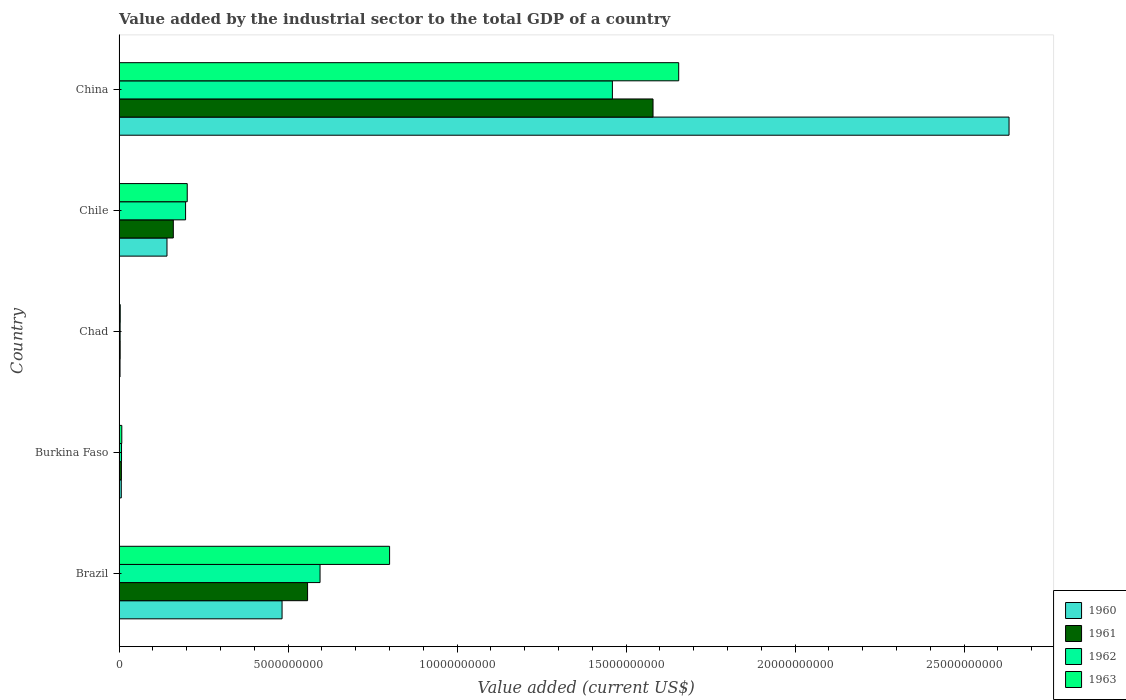How many different coloured bars are there?
Your response must be concise. 4. How many groups of bars are there?
Provide a short and direct response. 5. Are the number of bars per tick equal to the number of legend labels?
Your answer should be very brief. Yes. How many bars are there on the 4th tick from the top?
Provide a succinct answer. 4. What is the label of the 5th group of bars from the top?
Provide a short and direct response. Brazil. In how many cases, is the number of bars for a given country not equal to the number of legend labels?
Offer a very short reply. 0. What is the value added by the industrial sector to the total GDP in 1962 in Chile?
Offer a terse response. 1.97e+09. Across all countries, what is the maximum value added by the industrial sector to the total GDP in 1962?
Provide a succinct answer. 1.46e+1. Across all countries, what is the minimum value added by the industrial sector to the total GDP in 1962?
Keep it short and to the point. 3.17e+07. In which country was the value added by the industrial sector to the total GDP in 1963 minimum?
Keep it short and to the point. Chad. What is the total value added by the industrial sector to the total GDP in 1961 in the graph?
Offer a terse response. 2.31e+1. What is the difference between the value added by the industrial sector to the total GDP in 1963 in Brazil and that in China?
Keep it short and to the point. -8.55e+09. What is the difference between the value added by the industrial sector to the total GDP in 1962 in Chad and the value added by the industrial sector to the total GDP in 1963 in Brazil?
Your response must be concise. -7.97e+09. What is the average value added by the industrial sector to the total GDP in 1961 per country?
Your response must be concise. 4.62e+09. What is the difference between the value added by the industrial sector to the total GDP in 1962 and value added by the industrial sector to the total GDP in 1963 in Brazil?
Ensure brevity in your answer.  -2.06e+09. In how many countries, is the value added by the industrial sector to the total GDP in 1960 greater than 10000000000 US$?
Your answer should be compact. 1. What is the ratio of the value added by the industrial sector to the total GDP in 1961 in Brazil to that in Chad?
Your answer should be very brief. 170.8. What is the difference between the highest and the second highest value added by the industrial sector to the total GDP in 1963?
Offer a terse response. 8.55e+09. What is the difference between the highest and the lowest value added by the industrial sector to the total GDP in 1961?
Give a very brief answer. 1.58e+1. In how many countries, is the value added by the industrial sector to the total GDP in 1961 greater than the average value added by the industrial sector to the total GDP in 1961 taken over all countries?
Offer a terse response. 2. Is the sum of the value added by the industrial sector to the total GDP in 1962 in Burkina Faso and Chad greater than the maximum value added by the industrial sector to the total GDP in 1960 across all countries?
Make the answer very short. No. What does the 3rd bar from the top in Burkina Faso represents?
Offer a very short reply. 1961. Is it the case that in every country, the sum of the value added by the industrial sector to the total GDP in 1961 and value added by the industrial sector to the total GDP in 1960 is greater than the value added by the industrial sector to the total GDP in 1962?
Keep it short and to the point. Yes. How many countries are there in the graph?
Your answer should be compact. 5. Does the graph contain grids?
Provide a succinct answer. No. How many legend labels are there?
Provide a succinct answer. 4. What is the title of the graph?
Keep it short and to the point. Value added by the industrial sector to the total GDP of a country. Does "1971" appear as one of the legend labels in the graph?
Your answer should be compact. No. What is the label or title of the X-axis?
Keep it short and to the point. Value added (current US$). What is the label or title of the Y-axis?
Give a very brief answer. Country. What is the Value added (current US$) of 1960 in Brazil?
Ensure brevity in your answer.  4.82e+09. What is the Value added (current US$) in 1961 in Brazil?
Your answer should be compact. 5.58e+09. What is the Value added (current US$) of 1962 in Brazil?
Provide a succinct answer. 5.95e+09. What is the Value added (current US$) of 1963 in Brazil?
Offer a very short reply. 8.00e+09. What is the Value added (current US$) of 1960 in Burkina Faso?
Keep it short and to the point. 6.58e+07. What is the Value added (current US$) of 1961 in Burkina Faso?
Give a very brief answer. 6.97e+07. What is the Value added (current US$) of 1962 in Burkina Faso?
Provide a short and direct response. 7.35e+07. What is the Value added (current US$) in 1963 in Burkina Faso?
Give a very brief answer. 8.13e+07. What is the Value added (current US$) of 1960 in Chad?
Offer a very short reply. 2.88e+07. What is the Value added (current US$) of 1961 in Chad?
Provide a short and direct response. 3.27e+07. What is the Value added (current US$) in 1962 in Chad?
Ensure brevity in your answer.  3.17e+07. What is the Value added (current US$) of 1963 in Chad?
Your response must be concise. 3.49e+07. What is the Value added (current US$) in 1960 in Chile?
Provide a succinct answer. 1.42e+09. What is the Value added (current US$) of 1961 in Chile?
Provide a succinct answer. 1.61e+09. What is the Value added (current US$) in 1962 in Chile?
Make the answer very short. 1.97e+09. What is the Value added (current US$) of 1963 in Chile?
Your answer should be very brief. 2.02e+09. What is the Value added (current US$) in 1960 in China?
Provide a succinct answer. 2.63e+1. What is the Value added (current US$) of 1961 in China?
Keep it short and to the point. 1.58e+1. What is the Value added (current US$) in 1962 in China?
Give a very brief answer. 1.46e+1. What is the Value added (current US$) in 1963 in China?
Your answer should be compact. 1.66e+1. Across all countries, what is the maximum Value added (current US$) in 1960?
Give a very brief answer. 2.63e+1. Across all countries, what is the maximum Value added (current US$) in 1961?
Offer a very short reply. 1.58e+1. Across all countries, what is the maximum Value added (current US$) in 1962?
Make the answer very short. 1.46e+1. Across all countries, what is the maximum Value added (current US$) of 1963?
Your answer should be very brief. 1.66e+1. Across all countries, what is the minimum Value added (current US$) of 1960?
Ensure brevity in your answer.  2.88e+07. Across all countries, what is the minimum Value added (current US$) of 1961?
Your response must be concise. 3.27e+07. Across all countries, what is the minimum Value added (current US$) of 1962?
Your answer should be compact. 3.17e+07. Across all countries, what is the minimum Value added (current US$) of 1963?
Your response must be concise. 3.49e+07. What is the total Value added (current US$) of 1960 in the graph?
Provide a short and direct response. 3.27e+1. What is the total Value added (current US$) of 1961 in the graph?
Offer a very short reply. 2.31e+1. What is the total Value added (current US$) in 1962 in the graph?
Provide a short and direct response. 2.26e+1. What is the total Value added (current US$) of 1963 in the graph?
Offer a very short reply. 2.67e+1. What is the difference between the Value added (current US$) in 1960 in Brazil and that in Burkina Faso?
Your answer should be compact. 4.76e+09. What is the difference between the Value added (current US$) of 1961 in Brazil and that in Burkina Faso?
Give a very brief answer. 5.51e+09. What is the difference between the Value added (current US$) in 1962 in Brazil and that in Burkina Faso?
Your answer should be compact. 5.87e+09. What is the difference between the Value added (current US$) of 1963 in Brazil and that in Burkina Faso?
Your answer should be compact. 7.92e+09. What is the difference between the Value added (current US$) in 1960 in Brazil and that in Chad?
Your answer should be compact. 4.79e+09. What is the difference between the Value added (current US$) of 1961 in Brazil and that in Chad?
Give a very brief answer. 5.54e+09. What is the difference between the Value added (current US$) of 1962 in Brazil and that in Chad?
Your response must be concise. 5.91e+09. What is the difference between the Value added (current US$) of 1963 in Brazil and that in Chad?
Provide a short and direct response. 7.97e+09. What is the difference between the Value added (current US$) of 1960 in Brazil and that in Chile?
Make the answer very short. 3.40e+09. What is the difference between the Value added (current US$) in 1961 in Brazil and that in Chile?
Your answer should be very brief. 3.97e+09. What is the difference between the Value added (current US$) of 1962 in Brazil and that in Chile?
Make the answer very short. 3.98e+09. What is the difference between the Value added (current US$) of 1963 in Brazil and that in Chile?
Give a very brief answer. 5.99e+09. What is the difference between the Value added (current US$) in 1960 in Brazil and that in China?
Give a very brief answer. -2.15e+1. What is the difference between the Value added (current US$) of 1961 in Brazil and that in China?
Your answer should be very brief. -1.02e+1. What is the difference between the Value added (current US$) in 1962 in Brazil and that in China?
Provide a short and direct response. -8.65e+09. What is the difference between the Value added (current US$) of 1963 in Brazil and that in China?
Your answer should be compact. -8.55e+09. What is the difference between the Value added (current US$) of 1960 in Burkina Faso and that in Chad?
Provide a succinct answer. 3.70e+07. What is the difference between the Value added (current US$) in 1961 in Burkina Faso and that in Chad?
Offer a very short reply. 3.70e+07. What is the difference between the Value added (current US$) in 1962 in Burkina Faso and that in Chad?
Your response must be concise. 4.18e+07. What is the difference between the Value added (current US$) in 1963 in Burkina Faso and that in Chad?
Ensure brevity in your answer.  4.64e+07. What is the difference between the Value added (current US$) in 1960 in Burkina Faso and that in Chile?
Offer a very short reply. -1.35e+09. What is the difference between the Value added (current US$) of 1961 in Burkina Faso and that in Chile?
Your response must be concise. -1.54e+09. What is the difference between the Value added (current US$) in 1962 in Burkina Faso and that in Chile?
Your answer should be very brief. -1.89e+09. What is the difference between the Value added (current US$) in 1963 in Burkina Faso and that in Chile?
Your response must be concise. -1.94e+09. What is the difference between the Value added (current US$) of 1960 in Burkina Faso and that in China?
Give a very brief answer. -2.63e+1. What is the difference between the Value added (current US$) in 1961 in Burkina Faso and that in China?
Provide a succinct answer. -1.57e+1. What is the difference between the Value added (current US$) of 1962 in Burkina Faso and that in China?
Offer a very short reply. -1.45e+1. What is the difference between the Value added (current US$) in 1963 in Burkina Faso and that in China?
Keep it short and to the point. -1.65e+1. What is the difference between the Value added (current US$) of 1960 in Chad and that in Chile?
Your response must be concise. -1.39e+09. What is the difference between the Value added (current US$) in 1961 in Chad and that in Chile?
Your answer should be compact. -1.57e+09. What is the difference between the Value added (current US$) of 1962 in Chad and that in Chile?
Give a very brief answer. -1.94e+09. What is the difference between the Value added (current US$) in 1963 in Chad and that in Chile?
Provide a short and direct response. -1.98e+09. What is the difference between the Value added (current US$) in 1960 in Chad and that in China?
Provide a short and direct response. -2.63e+1. What is the difference between the Value added (current US$) of 1961 in Chad and that in China?
Your response must be concise. -1.58e+1. What is the difference between the Value added (current US$) in 1962 in Chad and that in China?
Your answer should be very brief. -1.46e+1. What is the difference between the Value added (current US$) in 1963 in Chad and that in China?
Give a very brief answer. -1.65e+1. What is the difference between the Value added (current US$) of 1960 in Chile and that in China?
Keep it short and to the point. -2.49e+1. What is the difference between the Value added (current US$) of 1961 in Chile and that in China?
Provide a short and direct response. -1.42e+1. What is the difference between the Value added (current US$) in 1962 in Chile and that in China?
Provide a short and direct response. -1.26e+1. What is the difference between the Value added (current US$) of 1963 in Chile and that in China?
Ensure brevity in your answer.  -1.45e+1. What is the difference between the Value added (current US$) in 1960 in Brazil and the Value added (current US$) in 1961 in Burkina Faso?
Your answer should be compact. 4.75e+09. What is the difference between the Value added (current US$) in 1960 in Brazil and the Value added (current US$) in 1962 in Burkina Faso?
Ensure brevity in your answer.  4.75e+09. What is the difference between the Value added (current US$) of 1960 in Brazil and the Value added (current US$) of 1963 in Burkina Faso?
Your answer should be very brief. 4.74e+09. What is the difference between the Value added (current US$) of 1961 in Brazil and the Value added (current US$) of 1962 in Burkina Faso?
Offer a very short reply. 5.50e+09. What is the difference between the Value added (current US$) in 1961 in Brazil and the Value added (current US$) in 1963 in Burkina Faso?
Ensure brevity in your answer.  5.50e+09. What is the difference between the Value added (current US$) of 1962 in Brazil and the Value added (current US$) of 1963 in Burkina Faso?
Provide a short and direct response. 5.86e+09. What is the difference between the Value added (current US$) of 1960 in Brazil and the Value added (current US$) of 1961 in Chad?
Keep it short and to the point. 4.79e+09. What is the difference between the Value added (current US$) in 1960 in Brazil and the Value added (current US$) in 1962 in Chad?
Offer a terse response. 4.79e+09. What is the difference between the Value added (current US$) of 1960 in Brazil and the Value added (current US$) of 1963 in Chad?
Make the answer very short. 4.79e+09. What is the difference between the Value added (current US$) in 1961 in Brazil and the Value added (current US$) in 1962 in Chad?
Provide a succinct answer. 5.55e+09. What is the difference between the Value added (current US$) of 1961 in Brazil and the Value added (current US$) of 1963 in Chad?
Your answer should be very brief. 5.54e+09. What is the difference between the Value added (current US$) in 1962 in Brazil and the Value added (current US$) in 1963 in Chad?
Offer a very short reply. 5.91e+09. What is the difference between the Value added (current US$) in 1960 in Brazil and the Value added (current US$) in 1961 in Chile?
Your response must be concise. 3.22e+09. What is the difference between the Value added (current US$) of 1960 in Brazil and the Value added (current US$) of 1962 in Chile?
Offer a terse response. 2.85e+09. What is the difference between the Value added (current US$) of 1960 in Brazil and the Value added (current US$) of 1963 in Chile?
Make the answer very short. 2.81e+09. What is the difference between the Value added (current US$) in 1961 in Brazil and the Value added (current US$) in 1962 in Chile?
Ensure brevity in your answer.  3.61e+09. What is the difference between the Value added (current US$) of 1961 in Brazil and the Value added (current US$) of 1963 in Chile?
Provide a short and direct response. 3.56e+09. What is the difference between the Value added (current US$) in 1962 in Brazil and the Value added (current US$) in 1963 in Chile?
Your answer should be compact. 3.93e+09. What is the difference between the Value added (current US$) of 1960 in Brazil and the Value added (current US$) of 1961 in China?
Your answer should be compact. -1.10e+1. What is the difference between the Value added (current US$) in 1960 in Brazil and the Value added (current US$) in 1962 in China?
Provide a short and direct response. -9.77e+09. What is the difference between the Value added (current US$) in 1960 in Brazil and the Value added (current US$) in 1963 in China?
Give a very brief answer. -1.17e+1. What is the difference between the Value added (current US$) of 1961 in Brazil and the Value added (current US$) of 1962 in China?
Ensure brevity in your answer.  -9.02e+09. What is the difference between the Value added (current US$) of 1961 in Brazil and the Value added (current US$) of 1963 in China?
Your answer should be compact. -1.10e+1. What is the difference between the Value added (current US$) in 1962 in Brazil and the Value added (current US$) in 1963 in China?
Your response must be concise. -1.06e+1. What is the difference between the Value added (current US$) of 1960 in Burkina Faso and the Value added (current US$) of 1961 in Chad?
Your answer should be compact. 3.32e+07. What is the difference between the Value added (current US$) in 1960 in Burkina Faso and the Value added (current US$) in 1962 in Chad?
Make the answer very short. 3.41e+07. What is the difference between the Value added (current US$) in 1960 in Burkina Faso and the Value added (current US$) in 1963 in Chad?
Your answer should be compact. 3.09e+07. What is the difference between the Value added (current US$) of 1961 in Burkina Faso and the Value added (current US$) of 1962 in Chad?
Ensure brevity in your answer.  3.79e+07. What is the difference between the Value added (current US$) in 1961 in Burkina Faso and the Value added (current US$) in 1963 in Chad?
Provide a succinct answer. 3.48e+07. What is the difference between the Value added (current US$) of 1962 in Burkina Faso and the Value added (current US$) of 1963 in Chad?
Keep it short and to the point. 3.86e+07. What is the difference between the Value added (current US$) of 1960 in Burkina Faso and the Value added (current US$) of 1961 in Chile?
Your answer should be compact. -1.54e+09. What is the difference between the Value added (current US$) of 1960 in Burkina Faso and the Value added (current US$) of 1962 in Chile?
Provide a succinct answer. -1.90e+09. What is the difference between the Value added (current US$) of 1960 in Burkina Faso and the Value added (current US$) of 1963 in Chile?
Offer a very short reply. -1.95e+09. What is the difference between the Value added (current US$) of 1961 in Burkina Faso and the Value added (current US$) of 1962 in Chile?
Make the answer very short. -1.90e+09. What is the difference between the Value added (current US$) in 1961 in Burkina Faso and the Value added (current US$) in 1963 in Chile?
Your response must be concise. -1.95e+09. What is the difference between the Value added (current US$) in 1962 in Burkina Faso and the Value added (current US$) in 1963 in Chile?
Make the answer very short. -1.94e+09. What is the difference between the Value added (current US$) in 1960 in Burkina Faso and the Value added (current US$) in 1961 in China?
Provide a succinct answer. -1.57e+1. What is the difference between the Value added (current US$) of 1960 in Burkina Faso and the Value added (current US$) of 1962 in China?
Keep it short and to the point. -1.45e+1. What is the difference between the Value added (current US$) of 1960 in Burkina Faso and the Value added (current US$) of 1963 in China?
Your response must be concise. -1.65e+1. What is the difference between the Value added (current US$) in 1961 in Burkina Faso and the Value added (current US$) in 1962 in China?
Provide a short and direct response. -1.45e+1. What is the difference between the Value added (current US$) of 1961 in Burkina Faso and the Value added (current US$) of 1963 in China?
Keep it short and to the point. -1.65e+1. What is the difference between the Value added (current US$) of 1962 in Burkina Faso and the Value added (current US$) of 1963 in China?
Your answer should be compact. -1.65e+1. What is the difference between the Value added (current US$) in 1960 in Chad and the Value added (current US$) in 1961 in Chile?
Provide a short and direct response. -1.58e+09. What is the difference between the Value added (current US$) in 1960 in Chad and the Value added (current US$) in 1962 in Chile?
Your answer should be compact. -1.94e+09. What is the difference between the Value added (current US$) in 1960 in Chad and the Value added (current US$) in 1963 in Chile?
Your answer should be compact. -1.99e+09. What is the difference between the Value added (current US$) in 1961 in Chad and the Value added (current US$) in 1962 in Chile?
Provide a short and direct response. -1.94e+09. What is the difference between the Value added (current US$) in 1961 in Chad and the Value added (current US$) in 1963 in Chile?
Offer a terse response. -1.98e+09. What is the difference between the Value added (current US$) in 1962 in Chad and the Value added (current US$) in 1963 in Chile?
Provide a short and direct response. -1.99e+09. What is the difference between the Value added (current US$) of 1960 in Chad and the Value added (current US$) of 1961 in China?
Give a very brief answer. -1.58e+1. What is the difference between the Value added (current US$) of 1960 in Chad and the Value added (current US$) of 1962 in China?
Provide a succinct answer. -1.46e+1. What is the difference between the Value added (current US$) in 1960 in Chad and the Value added (current US$) in 1963 in China?
Provide a short and direct response. -1.65e+1. What is the difference between the Value added (current US$) of 1961 in Chad and the Value added (current US$) of 1962 in China?
Offer a very short reply. -1.46e+1. What is the difference between the Value added (current US$) in 1961 in Chad and the Value added (current US$) in 1963 in China?
Provide a short and direct response. -1.65e+1. What is the difference between the Value added (current US$) in 1962 in Chad and the Value added (current US$) in 1963 in China?
Ensure brevity in your answer.  -1.65e+1. What is the difference between the Value added (current US$) in 1960 in Chile and the Value added (current US$) in 1961 in China?
Ensure brevity in your answer.  -1.44e+1. What is the difference between the Value added (current US$) of 1960 in Chile and the Value added (current US$) of 1962 in China?
Ensure brevity in your answer.  -1.32e+1. What is the difference between the Value added (current US$) in 1960 in Chile and the Value added (current US$) in 1963 in China?
Keep it short and to the point. -1.51e+1. What is the difference between the Value added (current US$) of 1961 in Chile and the Value added (current US$) of 1962 in China?
Your answer should be compact. -1.30e+1. What is the difference between the Value added (current US$) of 1961 in Chile and the Value added (current US$) of 1963 in China?
Your answer should be very brief. -1.50e+1. What is the difference between the Value added (current US$) of 1962 in Chile and the Value added (current US$) of 1963 in China?
Offer a very short reply. -1.46e+1. What is the average Value added (current US$) in 1960 per country?
Give a very brief answer. 6.53e+09. What is the average Value added (current US$) in 1961 per country?
Provide a succinct answer. 4.62e+09. What is the average Value added (current US$) in 1962 per country?
Keep it short and to the point. 4.52e+09. What is the average Value added (current US$) in 1963 per country?
Ensure brevity in your answer.  5.34e+09. What is the difference between the Value added (current US$) of 1960 and Value added (current US$) of 1961 in Brazil?
Offer a very short reply. -7.55e+08. What is the difference between the Value added (current US$) in 1960 and Value added (current US$) in 1962 in Brazil?
Keep it short and to the point. -1.12e+09. What is the difference between the Value added (current US$) of 1960 and Value added (current US$) of 1963 in Brazil?
Keep it short and to the point. -3.18e+09. What is the difference between the Value added (current US$) of 1961 and Value added (current US$) of 1962 in Brazil?
Make the answer very short. -3.69e+08. What is the difference between the Value added (current US$) in 1961 and Value added (current US$) in 1963 in Brazil?
Your response must be concise. -2.43e+09. What is the difference between the Value added (current US$) in 1962 and Value added (current US$) in 1963 in Brazil?
Ensure brevity in your answer.  -2.06e+09. What is the difference between the Value added (current US$) of 1960 and Value added (current US$) of 1961 in Burkina Faso?
Your answer should be compact. -3.88e+06. What is the difference between the Value added (current US$) in 1960 and Value added (current US$) in 1962 in Burkina Faso?
Your answer should be compact. -7.71e+06. What is the difference between the Value added (current US$) in 1960 and Value added (current US$) in 1963 in Burkina Faso?
Offer a terse response. -1.55e+07. What is the difference between the Value added (current US$) in 1961 and Value added (current US$) in 1962 in Burkina Faso?
Offer a terse response. -3.83e+06. What is the difference between the Value added (current US$) in 1961 and Value added (current US$) in 1963 in Burkina Faso?
Keep it short and to the point. -1.16e+07. What is the difference between the Value added (current US$) of 1962 and Value added (current US$) of 1963 in Burkina Faso?
Your answer should be compact. -7.75e+06. What is the difference between the Value added (current US$) in 1960 and Value added (current US$) in 1961 in Chad?
Provide a succinct answer. -3.82e+06. What is the difference between the Value added (current US$) of 1960 and Value added (current US$) of 1962 in Chad?
Your response must be concise. -2.90e+06. What is the difference between the Value added (current US$) of 1960 and Value added (current US$) of 1963 in Chad?
Give a very brief answer. -6.04e+06. What is the difference between the Value added (current US$) in 1961 and Value added (current US$) in 1962 in Chad?
Your answer should be very brief. 9.19e+05. What is the difference between the Value added (current US$) of 1961 and Value added (current US$) of 1963 in Chad?
Offer a very short reply. -2.22e+06. What is the difference between the Value added (current US$) of 1962 and Value added (current US$) of 1963 in Chad?
Provide a succinct answer. -3.14e+06. What is the difference between the Value added (current US$) in 1960 and Value added (current US$) in 1961 in Chile?
Make the answer very short. -1.88e+08. What is the difference between the Value added (current US$) in 1960 and Value added (current US$) in 1962 in Chile?
Your answer should be compact. -5.50e+08. What is the difference between the Value added (current US$) of 1960 and Value added (current US$) of 1963 in Chile?
Keep it short and to the point. -5.99e+08. What is the difference between the Value added (current US$) in 1961 and Value added (current US$) in 1962 in Chile?
Your answer should be very brief. -3.63e+08. What is the difference between the Value added (current US$) in 1961 and Value added (current US$) in 1963 in Chile?
Ensure brevity in your answer.  -4.12e+08. What is the difference between the Value added (current US$) in 1962 and Value added (current US$) in 1963 in Chile?
Your answer should be compact. -4.92e+07. What is the difference between the Value added (current US$) of 1960 and Value added (current US$) of 1961 in China?
Your answer should be very brief. 1.05e+1. What is the difference between the Value added (current US$) of 1960 and Value added (current US$) of 1962 in China?
Your answer should be compact. 1.17e+1. What is the difference between the Value added (current US$) in 1960 and Value added (current US$) in 1963 in China?
Your answer should be very brief. 9.77e+09. What is the difference between the Value added (current US$) of 1961 and Value added (current US$) of 1962 in China?
Your answer should be compact. 1.20e+09. What is the difference between the Value added (current US$) in 1961 and Value added (current US$) in 1963 in China?
Offer a terse response. -7.60e+08. What is the difference between the Value added (current US$) of 1962 and Value added (current US$) of 1963 in China?
Your answer should be very brief. -1.96e+09. What is the ratio of the Value added (current US$) of 1960 in Brazil to that in Burkina Faso?
Offer a terse response. 73.29. What is the ratio of the Value added (current US$) of 1961 in Brazil to that in Burkina Faso?
Your answer should be compact. 80.04. What is the ratio of the Value added (current US$) of 1962 in Brazil to that in Burkina Faso?
Your answer should be compact. 80.89. What is the ratio of the Value added (current US$) in 1963 in Brazil to that in Burkina Faso?
Keep it short and to the point. 98.49. What is the ratio of the Value added (current US$) in 1960 in Brazil to that in Chad?
Provide a short and direct response. 167.26. What is the ratio of the Value added (current US$) in 1961 in Brazil to that in Chad?
Your answer should be very brief. 170.8. What is the ratio of the Value added (current US$) in 1962 in Brazil to that in Chad?
Your answer should be compact. 187.38. What is the ratio of the Value added (current US$) in 1963 in Brazil to that in Chad?
Give a very brief answer. 229.53. What is the ratio of the Value added (current US$) in 1960 in Brazil to that in Chile?
Offer a very short reply. 3.4. What is the ratio of the Value added (current US$) in 1961 in Brazil to that in Chile?
Provide a short and direct response. 3.47. What is the ratio of the Value added (current US$) of 1962 in Brazil to that in Chile?
Provide a succinct answer. 3.02. What is the ratio of the Value added (current US$) in 1963 in Brazil to that in Chile?
Your answer should be compact. 3.97. What is the ratio of the Value added (current US$) in 1960 in Brazil to that in China?
Make the answer very short. 0.18. What is the ratio of the Value added (current US$) in 1961 in Brazil to that in China?
Ensure brevity in your answer.  0.35. What is the ratio of the Value added (current US$) in 1962 in Brazil to that in China?
Your answer should be compact. 0.41. What is the ratio of the Value added (current US$) of 1963 in Brazil to that in China?
Ensure brevity in your answer.  0.48. What is the ratio of the Value added (current US$) in 1960 in Burkina Faso to that in Chad?
Give a very brief answer. 2.28. What is the ratio of the Value added (current US$) of 1961 in Burkina Faso to that in Chad?
Your answer should be compact. 2.13. What is the ratio of the Value added (current US$) in 1962 in Burkina Faso to that in Chad?
Your answer should be very brief. 2.32. What is the ratio of the Value added (current US$) in 1963 in Burkina Faso to that in Chad?
Provide a succinct answer. 2.33. What is the ratio of the Value added (current US$) in 1960 in Burkina Faso to that in Chile?
Offer a very short reply. 0.05. What is the ratio of the Value added (current US$) of 1961 in Burkina Faso to that in Chile?
Offer a very short reply. 0.04. What is the ratio of the Value added (current US$) of 1962 in Burkina Faso to that in Chile?
Offer a very short reply. 0.04. What is the ratio of the Value added (current US$) in 1963 in Burkina Faso to that in Chile?
Ensure brevity in your answer.  0.04. What is the ratio of the Value added (current US$) in 1960 in Burkina Faso to that in China?
Your answer should be very brief. 0. What is the ratio of the Value added (current US$) of 1961 in Burkina Faso to that in China?
Keep it short and to the point. 0. What is the ratio of the Value added (current US$) of 1962 in Burkina Faso to that in China?
Provide a short and direct response. 0.01. What is the ratio of the Value added (current US$) of 1963 in Burkina Faso to that in China?
Your response must be concise. 0. What is the ratio of the Value added (current US$) of 1960 in Chad to that in Chile?
Keep it short and to the point. 0.02. What is the ratio of the Value added (current US$) of 1961 in Chad to that in Chile?
Give a very brief answer. 0.02. What is the ratio of the Value added (current US$) in 1962 in Chad to that in Chile?
Provide a short and direct response. 0.02. What is the ratio of the Value added (current US$) in 1963 in Chad to that in Chile?
Provide a short and direct response. 0.02. What is the ratio of the Value added (current US$) in 1960 in Chad to that in China?
Provide a short and direct response. 0. What is the ratio of the Value added (current US$) of 1961 in Chad to that in China?
Ensure brevity in your answer.  0. What is the ratio of the Value added (current US$) of 1962 in Chad to that in China?
Provide a succinct answer. 0. What is the ratio of the Value added (current US$) in 1963 in Chad to that in China?
Your response must be concise. 0. What is the ratio of the Value added (current US$) in 1960 in Chile to that in China?
Your answer should be compact. 0.05. What is the ratio of the Value added (current US$) of 1961 in Chile to that in China?
Make the answer very short. 0.1. What is the ratio of the Value added (current US$) in 1962 in Chile to that in China?
Keep it short and to the point. 0.13. What is the ratio of the Value added (current US$) in 1963 in Chile to that in China?
Offer a very short reply. 0.12. What is the difference between the highest and the second highest Value added (current US$) of 1960?
Provide a short and direct response. 2.15e+1. What is the difference between the highest and the second highest Value added (current US$) of 1961?
Provide a short and direct response. 1.02e+1. What is the difference between the highest and the second highest Value added (current US$) in 1962?
Provide a succinct answer. 8.65e+09. What is the difference between the highest and the second highest Value added (current US$) in 1963?
Offer a terse response. 8.55e+09. What is the difference between the highest and the lowest Value added (current US$) of 1960?
Your answer should be compact. 2.63e+1. What is the difference between the highest and the lowest Value added (current US$) in 1961?
Your response must be concise. 1.58e+1. What is the difference between the highest and the lowest Value added (current US$) in 1962?
Provide a succinct answer. 1.46e+1. What is the difference between the highest and the lowest Value added (current US$) in 1963?
Give a very brief answer. 1.65e+1. 